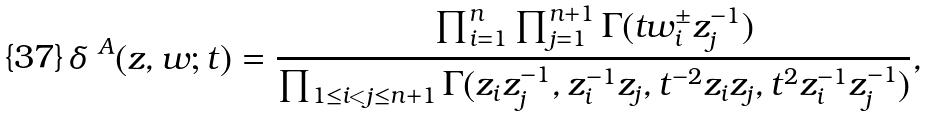Convert formula to latex. <formula><loc_0><loc_0><loc_500><loc_500>\delta ^ { \ A } ( z , w ; t ) = \frac { \prod _ { i = 1 } ^ { n } \prod _ { j = 1 } ^ { n + 1 } \Gamma ( t w _ { i } ^ { \pm } z _ { j } ^ { - 1 } ) } { \prod _ { 1 \leq i < j \leq n + 1 } \Gamma ( z _ { i } z _ { j } ^ { - 1 } , z _ { i } ^ { - 1 } z _ { j } , t ^ { - 2 } z _ { i } z _ { j } , t ^ { 2 } z _ { i } ^ { - 1 } z _ { j } ^ { - 1 } ) } ,</formula> 